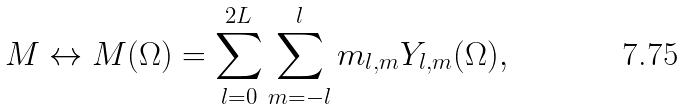Convert formula to latex. <formula><loc_0><loc_0><loc_500><loc_500>M \leftrightarrow M ( \Omega ) = \sum _ { l = 0 } ^ { 2 L } \sum _ { m = - l } ^ { l } m _ { l , m } Y _ { l , m } ( \Omega ) ,</formula> 